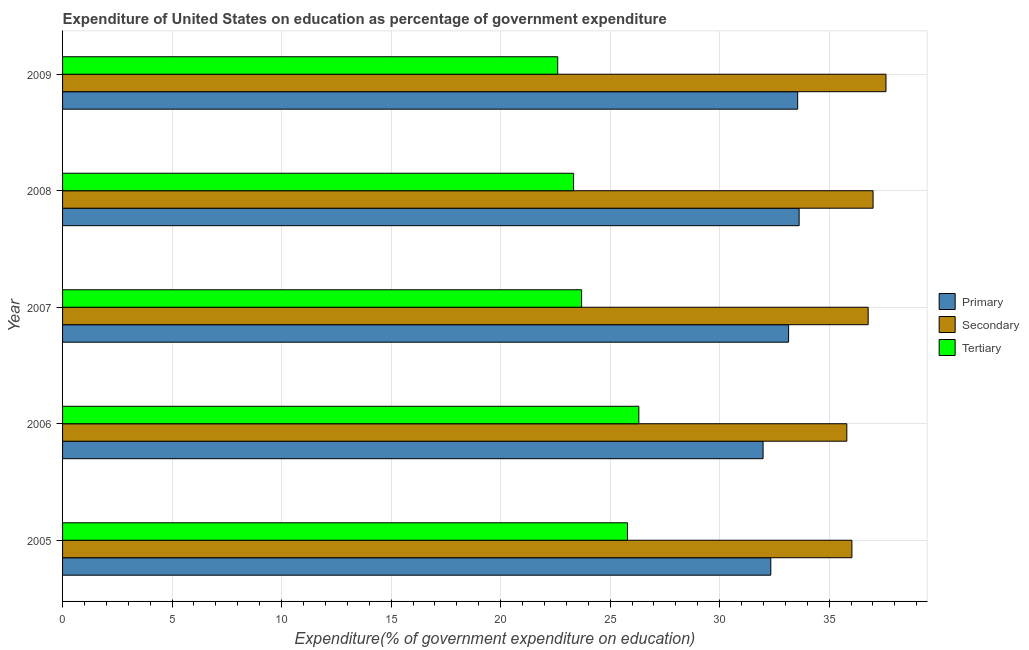How many different coloured bars are there?
Make the answer very short. 3. How many groups of bars are there?
Offer a very short reply. 5. Are the number of bars per tick equal to the number of legend labels?
Provide a short and direct response. Yes. How many bars are there on the 2nd tick from the top?
Keep it short and to the point. 3. How many bars are there on the 3rd tick from the bottom?
Give a very brief answer. 3. In how many cases, is the number of bars for a given year not equal to the number of legend labels?
Your response must be concise. 0. What is the expenditure on secondary education in 2005?
Your response must be concise. 36.04. Across all years, what is the maximum expenditure on primary education?
Your answer should be compact. 33.63. Across all years, what is the minimum expenditure on secondary education?
Ensure brevity in your answer.  35.81. In which year was the expenditure on secondary education maximum?
Offer a terse response. 2009. What is the total expenditure on secondary education in the graph?
Keep it short and to the point. 183.22. What is the difference between the expenditure on primary education in 2007 and that in 2009?
Keep it short and to the point. -0.41. What is the difference between the expenditure on primary education in 2008 and the expenditure on tertiary education in 2005?
Offer a terse response. 7.84. What is the average expenditure on secondary education per year?
Make the answer very short. 36.64. In the year 2007, what is the difference between the expenditure on primary education and expenditure on tertiary education?
Keep it short and to the point. 9.45. In how many years, is the expenditure on primary education greater than 20 %?
Make the answer very short. 5. What is the difference between the highest and the second highest expenditure on secondary education?
Make the answer very short. 0.59. What is the difference between the highest and the lowest expenditure on primary education?
Keep it short and to the point. 1.65. What does the 3rd bar from the top in 2006 represents?
Make the answer very short. Primary. What does the 3rd bar from the bottom in 2005 represents?
Your answer should be compact. Tertiary. How many bars are there?
Ensure brevity in your answer.  15. Are all the bars in the graph horizontal?
Offer a terse response. Yes. How many years are there in the graph?
Provide a short and direct response. 5. What is the difference between two consecutive major ticks on the X-axis?
Give a very brief answer. 5. Are the values on the major ticks of X-axis written in scientific E-notation?
Give a very brief answer. No. Does the graph contain any zero values?
Give a very brief answer. No. Does the graph contain grids?
Your answer should be compact. Yes. Where does the legend appear in the graph?
Ensure brevity in your answer.  Center right. What is the title of the graph?
Ensure brevity in your answer.  Expenditure of United States on education as percentage of government expenditure. Does "Food" appear as one of the legend labels in the graph?
Offer a terse response. No. What is the label or title of the X-axis?
Provide a succinct answer. Expenditure(% of government expenditure on education). What is the Expenditure(% of government expenditure on education) of Primary in 2005?
Give a very brief answer. 32.33. What is the Expenditure(% of government expenditure on education) in Secondary in 2005?
Your answer should be compact. 36.04. What is the Expenditure(% of government expenditure on education) in Tertiary in 2005?
Provide a short and direct response. 25.79. What is the Expenditure(% of government expenditure on education) of Primary in 2006?
Offer a very short reply. 31.98. What is the Expenditure(% of government expenditure on education) in Secondary in 2006?
Your answer should be very brief. 35.81. What is the Expenditure(% of government expenditure on education) in Tertiary in 2006?
Provide a succinct answer. 26.31. What is the Expenditure(% of government expenditure on education) in Primary in 2007?
Offer a very short reply. 33.15. What is the Expenditure(% of government expenditure on education) in Secondary in 2007?
Ensure brevity in your answer.  36.78. What is the Expenditure(% of government expenditure on education) of Tertiary in 2007?
Your response must be concise. 23.7. What is the Expenditure(% of government expenditure on education) of Primary in 2008?
Offer a terse response. 33.63. What is the Expenditure(% of government expenditure on education) of Secondary in 2008?
Provide a succinct answer. 37. What is the Expenditure(% of government expenditure on education) of Tertiary in 2008?
Keep it short and to the point. 23.33. What is the Expenditure(% of government expenditure on education) in Primary in 2009?
Your answer should be compact. 33.56. What is the Expenditure(% of government expenditure on education) in Secondary in 2009?
Give a very brief answer. 37.59. What is the Expenditure(% of government expenditure on education) of Tertiary in 2009?
Provide a succinct answer. 22.61. Across all years, what is the maximum Expenditure(% of government expenditure on education) of Primary?
Ensure brevity in your answer.  33.63. Across all years, what is the maximum Expenditure(% of government expenditure on education) of Secondary?
Offer a terse response. 37.59. Across all years, what is the maximum Expenditure(% of government expenditure on education) of Tertiary?
Offer a terse response. 26.31. Across all years, what is the minimum Expenditure(% of government expenditure on education) of Primary?
Give a very brief answer. 31.98. Across all years, what is the minimum Expenditure(% of government expenditure on education) of Secondary?
Your answer should be very brief. 35.81. Across all years, what is the minimum Expenditure(% of government expenditure on education) of Tertiary?
Give a very brief answer. 22.61. What is the total Expenditure(% of government expenditure on education) in Primary in the graph?
Offer a very short reply. 164.66. What is the total Expenditure(% of government expenditure on education) in Secondary in the graph?
Provide a succinct answer. 183.22. What is the total Expenditure(% of government expenditure on education) of Tertiary in the graph?
Offer a terse response. 121.74. What is the difference between the Expenditure(% of government expenditure on education) in Primary in 2005 and that in 2006?
Offer a terse response. 0.35. What is the difference between the Expenditure(% of government expenditure on education) of Secondary in 2005 and that in 2006?
Your answer should be compact. 0.23. What is the difference between the Expenditure(% of government expenditure on education) in Tertiary in 2005 and that in 2006?
Offer a very short reply. -0.52. What is the difference between the Expenditure(% of government expenditure on education) in Primary in 2005 and that in 2007?
Provide a short and direct response. -0.81. What is the difference between the Expenditure(% of government expenditure on education) of Secondary in 2005 and that in 2007?
Offer a terse response. -0.74. What is the difference between the Expenditure(% of government expenditure on education) in Tertiary in 2005 and that in 2007?
Keep it short and to the point. 2.09. What is the difference between the Expenditure(% of government expenditure on education) of Primary in 2005 and that in 2008?
Your answer should be compact. -1.29. What is the difference between the Expenditure(% of government expenditure on education) of Secondary in 2005 and that in 2008?
Provide a succinct answer. -0.97. What is the difference between the Expenditure(% of government expenditure on education) in Tertiary in 2005 and that in 2008?
Ensure brevity in your answer.  2.46. What is the difference between the Expenditure(% of government expenditure on education) in Primary in 2005 and that in 2009?
Ensure brevity in your answer.  -1.23. What is the difference between the Expenditure(% of government expenditure on education) in Secondary in 2005 and that in 2009?
Ensure brevity in your answer.  -1.56. What is the difference between the Expenditure(% of government expenditure on education) in Tertiary in 2005 and that in 2009?
Offer a very short reply. 3.18. What is the difference between the Expenditure(% of government expenditure on education) of Primary in 2006 and that in 2007?
Provide a short and direct response. -1.16. What is the difference between the Expenditure(% of government expenditure on education) in Secondary in 2006 and that in 2007?
Provide a short and direct response. -0.97. What is the difference between the Expenditure(% of government expenditure on education) in Tertiary in 2006 and that in 2007?
Make the answer very short. 2.61. What is the difference between the Expenditure(% of government expenditure on education) of Primary in 2006 and that in 2008?
Provide a succinct answer. -1.65. What is the difference between the Expenditure(% of government expenditure on education) of Secondary in 2006 and that in 2008?
Your response must be concise. -1.2. What is the difference between the Expenditure(% of government expenditure on education) in Tertiary in 2006 and that in 2008?
Offer a very short reply. 2.98. What is the difference between the Expenditure(% of government expenditure on education) of Primary in 2006 and that in 2009?
Ensure brevity in your answer.  -1.58. What is the difference between the Expenditure(% of government expenditure on education) of Secondary in 2006 and that in 2009?
Your answer should be compact. -1.79. What is the difference between the Expenditure(% of government expenditure on education) of Tertiary in 2006 and that in 2009?
Make the answer very short. 3.7. What is the difference between the Expenditure(% of government expenditure on education) of Primary in 2007 and that in 2008?
Ensure brevity in your answer.  -0.48. What is the difference between the Expenditure(% of government expenditure on education) in Secondary in 2007 and that in 2008?
Make the answer very short. -0.22. What is the difference between the Expenditure(% of government expenditure on education) of Tertiary in 2007 and that in 2008?
Make the answer very short. 0.37. What is the difference between the Expenditure(% of government expenditure on education) in Primary in 2007 and that in 2009?
Ensure brevity in your answer.  -0.41. What is the difference between the Expenditure(% of government expenditure on education) of Secondary in 2007 and that in 2009?
Your response must be concise. -0.81. What is the difference between the Expenditure(% of government expenditure on education) of Tertiary in 2007 and that in 2009?
Give a very brief answer. 1.09. What is the difference between the Expenditure(% of government expenditure on education) in Primary in 2008 and that in 2009?
Offer a very short reply. 0.07. What is the difference between the Expenditure(% of government expenditure on education) in Secondary in 2008 and that in 2009?
Provide a succinct answer. -0.59. What is the difference between the Expenditure(% of government expenditure on education) of Tertiary in 2008 and that in 2009?
Make the answer very short. 0.72. What is the difference between the Expenditure(% of government expenditure on education) of Primary in 2005 and the Expenditure(% of government expenditure on education) of Secondary in 2006?
Make the answer very short. -3.47. What is the difference between the Expenditure(% of government expenditure on education) in Primary in 2005 and the Expenditure(% of government expenditure on education) in Tertiary in 2006?
Your answer should be very brief. 6.02. What is the difference between the Expenditure(% of government expenditure on education) in Secondary in 2005 and the Expenditure(% of government expenditure on education) in Tertiary in 2006?
Your answer should be very brief. 9.73. What is the difference between the Expenditure(% of government expenditure on education) of Primary in 2005 and the Expenditure(% of government expenditure on education) of Secondary in 2007?
Your response must be concise. -4.45. What is the difference between the Expenditure(% of government expenditure on education) in Primary in 2005 and the Expenditure(% of government expenditure on education) in Tertiary in 2007?
Make the answer very short. 8.64. What is the difference between the Expenditure(% of government expenditure on education) of Secondary in 2005 and the Expenditure(% of government expenditure on education) of Tertiary in 2007?
Your answer should be very brief. 12.34. What is the difference between the Expenditure(% of government expenditure on education) in Primary in 2005 and the Expenditure(% of government expenditure on education) in Secondary in 2008?
Your answer should be very brief. -4.67. What is the difference between the Expenditure(% of government expenditure on education) in Primary in 2005 and the Expenditure(% of government expenditure on education) in Tertiary in 2008?
Give a very brief answer. 9. What is the difference between the Expenditure(% of government expenditure on education) of Secondary in 2005 and the Expenditure(% of government expenditure on education) of Tertiary in 2008?
Keep it short and to the point. 12.71. What is the difference between the Expenditure(% of government expenditure on education) of Primary in 2005 and the Expenditure(% of government expenditure on education) of Secondary in 2009?
Offer a terse response. -5.26. What is the difference between the Expenditure(% of government expenditure on education) in Primary in 2005 and the Expenditure(% of government expenditure on education) in Tertiary in 2009?
Keep it short and to the point. 9.73. What is the difference between the Expenditure(% of government expenditure on education) in Secondary in 2005 and the Expenditure(% of government expenditure on education) in Tertiary in 2009?
Offer a terse response. 13.43. What is the difference between the Expenditure(% of government expenditure on education) of Primary in 2006 and the Expenditure(% of government expenditure on education) of Secondary in 2007?
Ensure brevity in your answer.  -4.8. What is the difference between the Expenditure(% of government expenditure on education) of Primary in 2006 and the Expenditure(% of government expenditure on education) of Tertiary in 2007?
Your response must be concise. 8.29. What is the difference between the Expenditure(% of government expenditure on education) in Secondary in 2006 and the Expenditure(% of government expenditure on education) in Tertiary in 2007?
Your answer should be compact. 12.11. What is the difference between the Expenditure(% of government expenditure on education) in Primary in 2006 and the Expenditure(% of government expenditure on education) in Secondary in 2008?
Make the answer very short. -5.02. What is the difference between the Expenditure(% of government expenditure on education) of Primary in 2006 and the Expenditure(% of government expenditure on education) of Tertiary in 2008?
Ensure brevity in your answer.  8.65. What is the difference between the Expenditure(% of government expenditure on education) in Secondary in 2006 and the Expenditure(% of government expenditure on education) in Tertiary in 2008?
Offer a very short reply. 12.48. What is the difference between the Expenditure(% of government expenditure on education) in Primary in 2006 and the Expenditure(% of government expenditure on education) in Secondary in 2009?
Give a very brief answer. -5.61. What is the difference between the Expenditure(% of government expenditure on education) in Primary in 2006 and the Expenditure(% of government expenditure on education) in Tertiary in 2009?
Offer a terse response. 9.38. What is the difference between the Expenditure(% of government expenditure on education) of Secondary in 2006 and the Expenditure(% of government expenditure on education) of Tertiary in 2009?
Provide a succinct answer. 13.2. What is the difference between the Expenditure(% of government expenditure on education) in Primary in 2007 and the Expenditure(% of government expenditure on education) in Secondary in 2008?
Offer a very short reply. -3.86. What is the difference between the Expenditure(% of government expenditure on education) in Primary in 2007 and the Expenditure(% of government expenditure on education) in Tertiary in 2008?
Provide a short and direct response. 9.82. What is the difference between the Expenditure(% of government expenditure on education) of Secondary in 2007 and the Expenditure(% of government expenditure on education) of Tertiary in 2008?
Give a very brief answer. 13.45. What is the difference between the Expenditure(% of government expenditure on education) in Primary in 2007 and the Expenditure(% of government expenditure on education) in Secondary in 2009?
Give a very brief answer. -4.45. What is the difference between the Expenditure(% of government expenditure on education) of Primary in 2007 and the Expenditure(% of government expenditure on education) of Tertiary in 2009?
Offer a very short reply. 10.54. What is the difference between the Expenditure(% of government expenditure on education) in Secondary in 2007 and the Expenditure(% of government expenditure on education) in Tertiary in 2009?
Give a very brief answer. 14.17. What is the difference between the Expenditure(% of government expenditure on education) of Primary in 2008 and the Expenditure(% of government expenditure on education) of Secondary in 2009?
Keep it short and to the point. -3.96. What is the difference between the Expenditure(% of government expenditure on education) in Primary in 2008 and the Expenditure(% of government expenditure on education) in Tertiary in 2009?
Offer a terse response. 11.02. What is the difference between the Expenditure(% of government expenditure on education) in Secondary in 2008 and the Expenditure(% of government expenditure on education) in Tertiary in 2009?
Ensure brevity in your answer.  14.4. What is the average Expenditure(% of government expenditure on education) of Primary per year?
Ensure brevity in your answer.  32.93. What is the average Expenditure(% of government expenditure on education) of Secondary per year?
Your answer should be compact. 36.64. What is the average Expenditure(% of government expenditure on education) of Tertiary per year?
Ensure brevity in your answer.  24.35. In the year 2005, what is the difference between the Expenditure(% of government expenditure on education) of Primary and Expenditure(% of government expenditure on education) of Secondary?
Give a very brief answer. -3.7. In the year 2005, what is the difference between the Expenditure(% of government expenditure on education) of Primary and Expenditure(% of government expenditure on education) of Tertiary?
Give a very brief answer. 6.54. In the year 2005, what is the difference between the Expenditure(% of government expenditure on education) in Secondary and Expenditure(% of government expenditure on education) in Tertiary?
Provide a succinct answer. 10.25. In the year 2006, what is the difference between the Expenditure(% of government expenditure on education) in Primary and Expenditure(% of government expenditure on education) in Secondary?
Provide a short and direct response. -3.82. In the year 2006, what is the difference between the Expenditure(% of government expenditure on education) in Primary and Expenditure(% of government expenditure on education) in Tertiary?
Your response must be concise. 5.67. In the year 2006, what is the difference between the Expenditure(% of government expenditure on education) in Secondary and Expenditure(% of government expenditure on education) in Tertiary?
Your answer should be compact. 9.5. In the year 2007, what is the difference between the Expenditure(% of government expenditure on education) in Primary and Expenditure(% of government expenditure on education) in Secondary?
Ensure brevity in your answer.  -3.63. In the year 2007, what is the difference between the Expenditure(% of government expenditure on education) of Primary and Expenditure(% of government expenditure on education) of Tertiary?
Your answer should be very brief. 9.45. In the year 2007, what is the difference between the Expenditure(% of government expenditure on education) in Secondary and Expenditure(% of government expenditure on education) in Tertiary?
Your answer should be compact. 13.08. In the year 2008, what is the difference between the Expenditure(% of government expenditure on education) of Primary and Expenditure(% of government expenditure on education) of Secondary?
Provide a succinct answer. -3.38. In the year 2008, what is the difference between the Expenditure(% of government expenditure on education) of Primary and Expenditure(% of government expenditure on education) of Tertiary?
Give a very brief answer. 10.3. In the year 2008, what is the difference between the Expenditure(% of government expenditure on education) of Secondary and Expenditure(% of government expenditure on education) of Tertiary?
Provide a short and direct response. 13.67. In the year 2009, what is the difference between the Expenditure(% of government expenditure on education) in Primary and Expenditure(% of government expenditure on education) in Secondary?
Ensure brevity in your answer.  -4.03. In the year 2009, what is the difference between the Expenditure(% of government expenditure on education) of Primary and Expenditure(% of government expenditure on education) of Tertiary?
Offer a terse response. 10.96. In the year 2009, what is the difference between the Expenditure(% of government expenditure on education) in Secondary and Expenditure(% of government expenditure on education) in Tertiary?
Provide a short and direct response. 14.99. What is the ratio of the Expenditure(% of government expenditure on education) in Primary in 2005 to that in 2006?
Make the answer very short. 1.01. What is the ratio of the Expenditure(% of government expenditure on education) of Tertiary in 2005 to that in 2006?
Provide a succinct answer. 0.98. What is the ratio of the Expenditure(% of government expenditure on education) of Primary in 2005 to that in 2007?
Your response must be concise. 0.98. What is the ratio of the Expenditure(% of government expenditure on education) in Secondary in 2005 to that in 2007?
Keep it short and to the point. 0.98. What is the ratio of the Expenditure(% of government expenditure on education) of Tertiary in 2005 to that in 2007?
Ensure brevity in your answer.  1.09. What is the ratio of the Expenditure(% of government expenditure on education) of Primary in 2005 to that in 2008?
Your answer should be compact. 0.96. What is the ratio of the Expenditure(% of government expenditure on education) of Secondary in 2005 to that in 2008?
Your answer should be very brief. 0.97. What is the ratio of the Expenditure(% of government expenditure on education) in Tertiary in 2005 to that in 2008?
Your answer should be very brief. 1.11. What is the ratio of the Expenditure(% of government expenditure on education) of Primary in 2005 to that in 2009?
Your answer should be compact. 0.96. What is the ratio of the Expenditure(% of government expenditure on education) in Secondary in 2005 to that in 2009?
Offer a very short reply. 0.96. What is the ratio of the Expenditure(% of government expenditure on education) in Tertiary in 2005 to that in 2009?
Make the answer very short. 1.14. What is the ratio of the Expenditure(% of government expenditure on education) of Primary in 2006 to that in 2007?
Offer a very short reply. 0.96. What is the ratio of the Expenditure(% of government expenditure on education) of Secondary in 2006 to that in 2007?
Provide a short and direct response. 0.97. What is the ratio of the Expenditure(% of government expenditure on education) of Tertiary in 2006 to that in 2007?
Provide a short and direct response. 1.11. What is the ratio of the Expenditure(% of government expenditure on education) in Primary in 2006 to that in 2008?
Offer a very short reply. 0.95. What is the ratio of the Expenditure(% of government expenditure on education) in Secondary in 2006 to that in 2008?
Your response must be concise. 0.97. What is the ratio of the Expenditure(% of government expenditure on education) of Tertiary in 2006 to that in 2008?
Keep it short and to the point. 1.13. What is the ratio of the Expenditure(% of government expenditure on education) in Primary in 2006 to that in 2009?
Your answer should be compact. 0.95. What is the ratio of the Expenditure(% of government expenditure on education) of Tertiary in 2006 to that in 2009?
Ensure brevity in your answer.  1.16. What is the ratio of the Expenditure(% of government expenditure on education) in Primary in 2007 to that in 2008?
Keep it short and to the point. 0.99. What is the ratio of the Expenditure(% of government expenditure on education) of Secondary in 2007 to that in 2008?
Your answer should be very brief. 0.99. What is the ratio of the Expenditure(% of government expenditure on education) of Tertiary in 2007 to that in 2008?
Provide a succinct answer. 1.02. What is the ratio of the Expenditure(% of government expenditure on education) in Primary in 2007 to that in 2009?
Make the answer very short. 0.99. What is the ratio of the Expenditure(% of government expenditure on education) of Secondary in 2007 to that in 2009?
Make the answer very short. 0.98. What is the ratio of the Expenditure(% of government expenditure on education) in Tertiary in 2007 to that in 2009?
Provide a short and direct response. 1.05. What is the ratio of the Expenditure(% of government expenditure on education) in Secondary in 2008 to that in 2009?
Ensure brevity in your answer.  0.98. What is the ratio of the Expenditure(% of government expenditure on education) in Tertiary in 2008 to that in 2009?
Your response must be concise. 1.03. What is the difference between the highest and the second highest Expenditure(% of government expenditure on education) in Primary?
Your response must be concise. 0.07. What is the difference between the highest and the second highest Expenditure(% of government expenditure on education) in Secondary?
Ensure brevity in your answer.  0.59. What is the difference between the highest and the second highest Expenditure(% of government expenditure on education) in Tertiary?
Your answer should be compact. 0.52. What is the difference between the highest and the lowest Expenditure(% of government expenditure on education) in Primary?
Your answer should be compact. 1.65. What is the difference between the highest and the lowest Expenditure(% of government expenditure on education) of Secondary?
Ensure brevity in your answer.  1.79. What is the difference between the highest and the lowest Expenditure(% of government expenditure on education) in Tertiary?
Offer a very short reply. 3.7. 